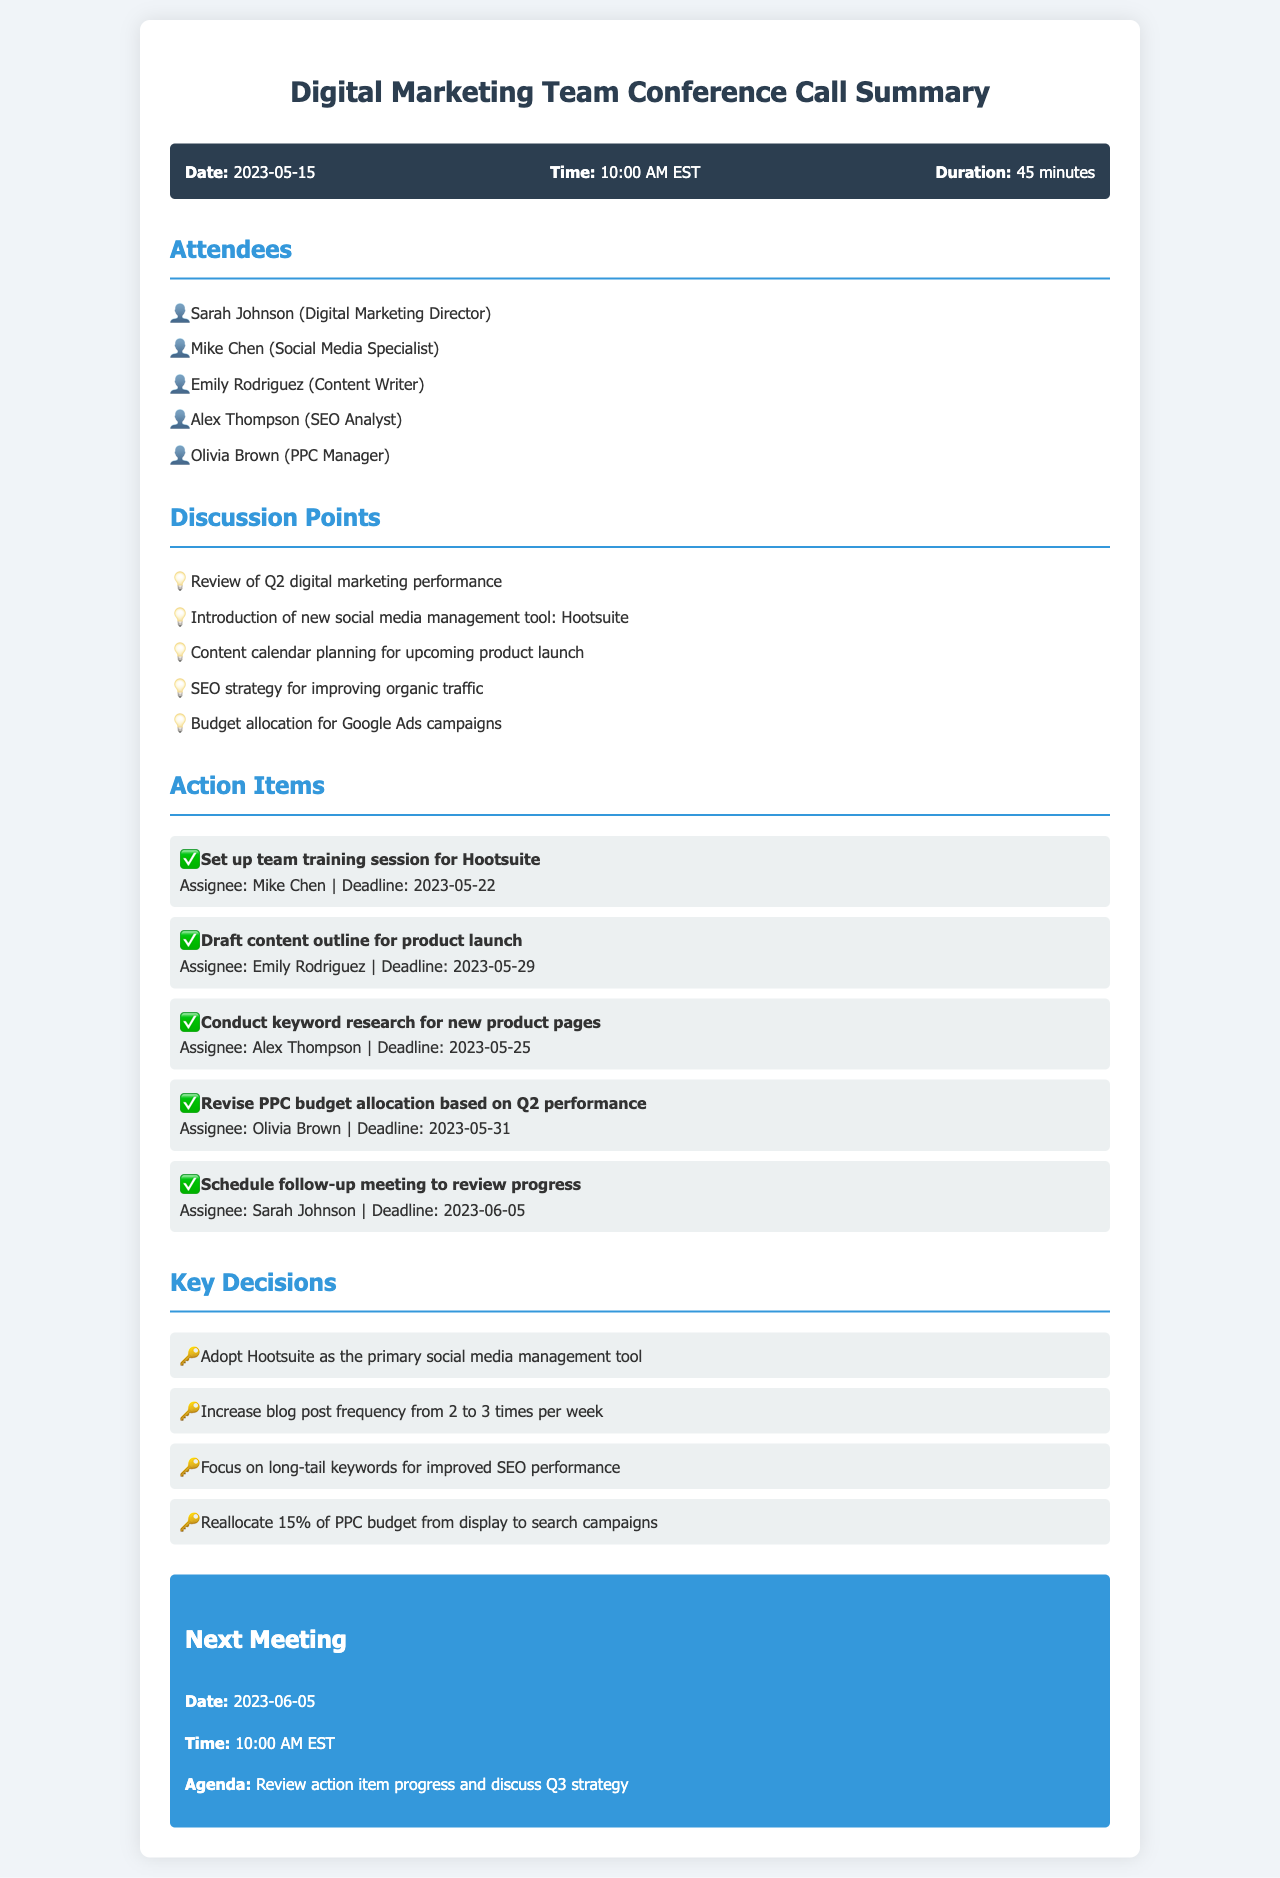What is the date of the conference call? The date of the conference call is stated in the call information section.
Answer: 2023-05-15 Who is the Digital Marketing Director? The Digital Marketing Director is listed among the attendees at the top of the document.
Answer: Sarah Johnson What is the duration of the call? The duration of the call can be found in the call information section.
Answer: 45 minutes What is one of the discussion points mentioned? The discussion points can be found under the corresponding section, and any item listed there serves as an answer.
Answer: Review of Q2 digital marketing performance Who is responsible for setting up the Hootsuite training session? The action items section specifies who is assigned to each task listed there.
Answer: Mike Chen What is the deadline for drafting the content outline? The deadlines for the action items are listed in the action items section of the document.
Answer: 2023-05-29 What percentage of the PPC budget is to be reallocated from display to search campaigns? This decision is stated under the key decisions section of the document.
Answer: 15% When is the next meeting scheduled? The next meeting date is provided in the next meeting section of the document.
Answer: 2023-06-05 What is the agenda for the next meeting? The agenda for the next meeting is explicitly mentioned in the next meeting section.
Answer: Review action item progress and discuss Q3 strategy 